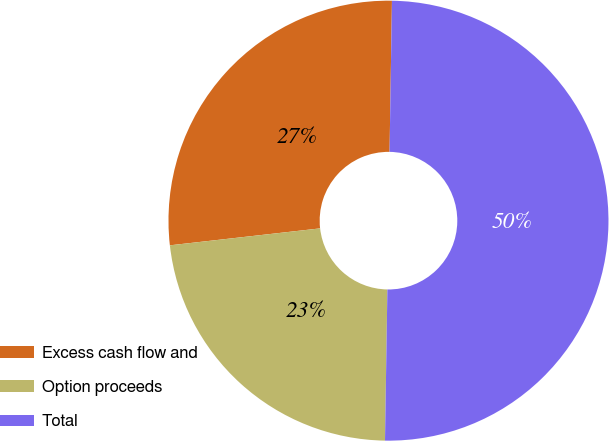<chart> <loc_0><loc_0><loc_500><loc_500><pie_chart><fcel>Excess cash flow and<fcel>Option proceeds<fcel>Total<nl><fcel>27.04%<fcel>22.96%<fcel>50.0%<nl></chart> 